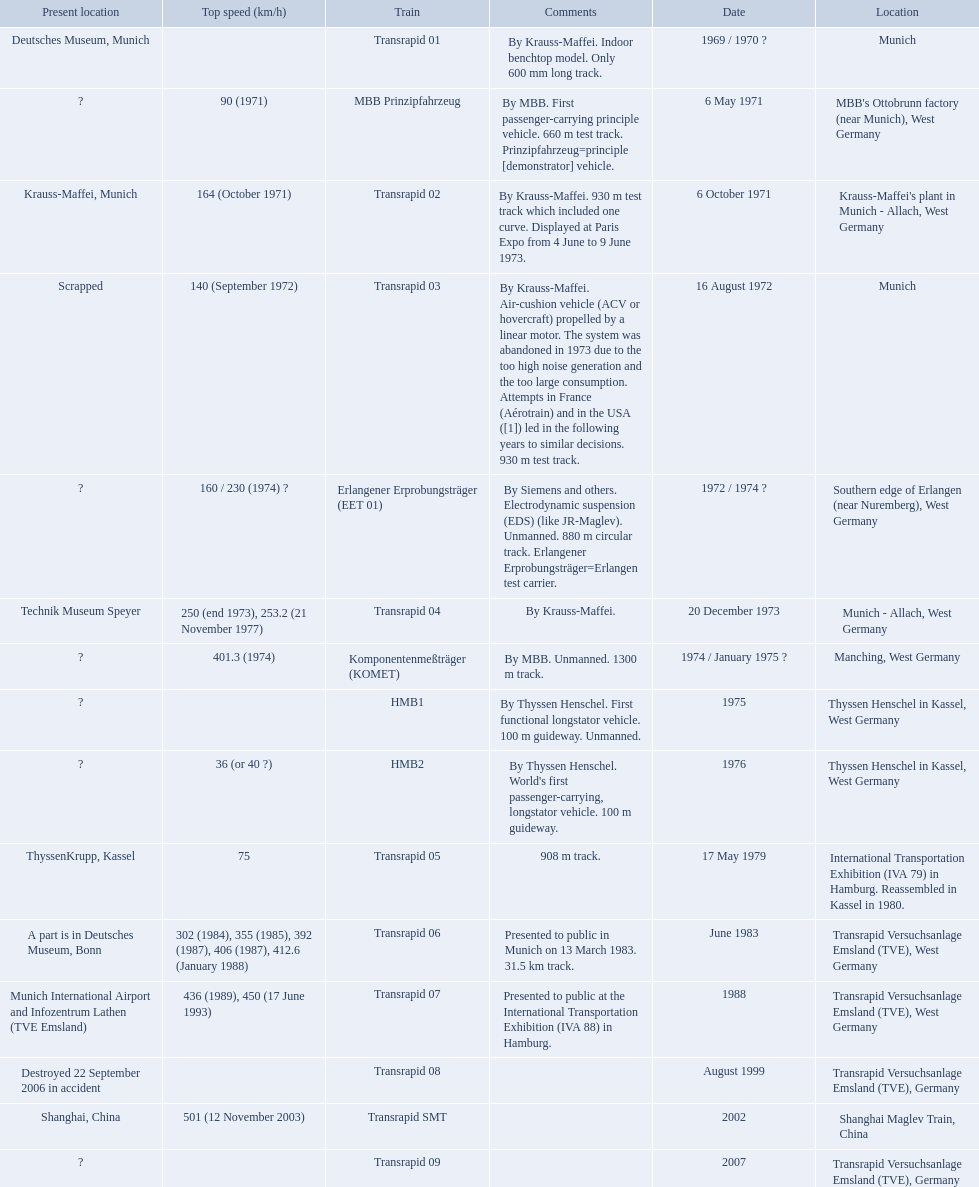Which trains had a top speed listed? MBB Prinzipfahrzeug, Transrapid 02, Transrapid 03, Erlangener Erprobungsträger (EET 01), Transrapid 04, Komponentenmeßträger (KOMET), HMB2, Transrapid 05, Transrapid 06, Transrapid 07, Transrapid SMT. Which ones list munich as a location? MBB Prinzipfahrzeug, Transrapid 02, Transrapid 03. Of these which ones present location is known? Transrapid 02, Transrapid 03. Which of those is no longer in operation? Transrapid 03. 